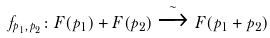Convert formula to latex. <formula><loc_0><loc_0><loc_500><loc_500>f _ { p _ { 1 } , p _ { 2 } } \colon F ( p _ { 1 } ) + F ( p _ { 2 } ) \xrightarrow { \sim } F ( p _ { 1 } + p _ { 2 } )</formula> 